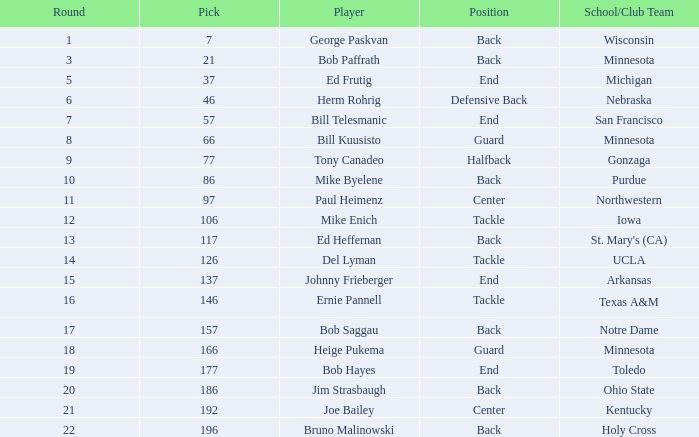What was the highest pick for a player from a school or club team of Arkansas? 137.0. 